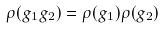Convert formula to latex. <formula><loc_0><loc_0><loc_500><loc_500>\rho ( g _ { 1 } g _ { 2 } ) = \rho ( g _ { 1 } ) \rho ( g _ { 2 } )</formula> 